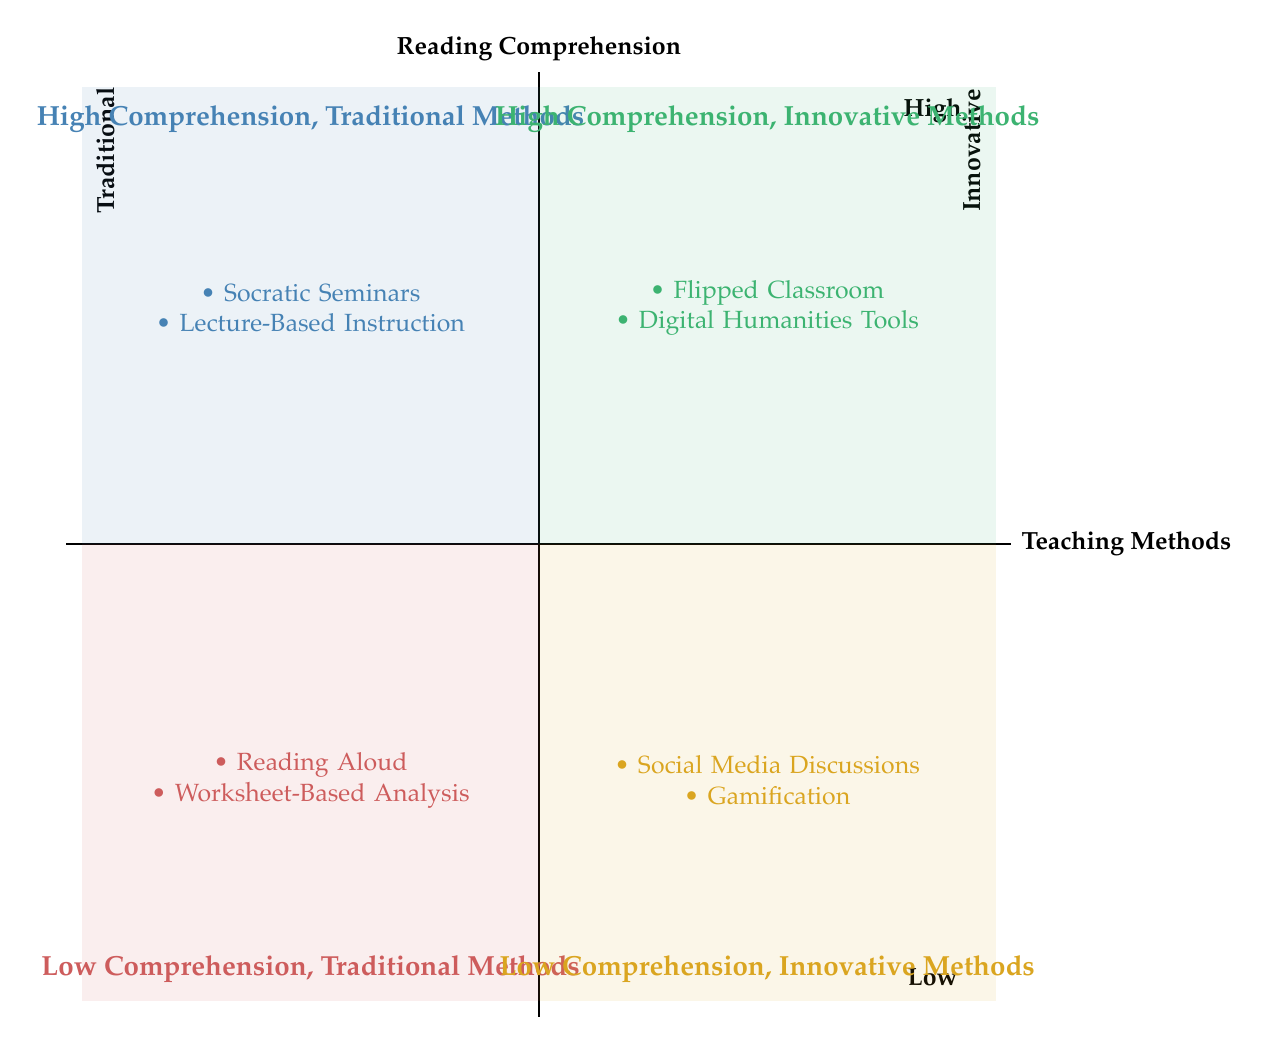What teaching method is in Quadrant 1? Quadrant 1 lists Socratic Seminars and Lecture-Based Instruction as the teaching methods; the question specifically asks for a method, and the first listed is Socratic Seminars.
Answer: Socratic Seminars How many teaching methods are in Quadrant 3? Quadrant 3 contains two methods: Reading Aloud and Worksheet-Based Analysis; counting the elements gives us the number.
Answer: 2 What is the relationship between innovative methods and high comprehension? Quadrant 2 represents the combination of High Comprehension and Innovative Methods, suggesting a positive relationship between innovation in teaching and comprehension levels.
Answer: Positive relationship Which quadrant contains Gamification? Gamification is listed in Quadrant 4; this quadrant corresponds to Low Comprehension and Innovative Methods.
Answer: Quadrant 4 Which traditional method aims to foster critical thinking? Socratic Seminars is found in Quadrant 1, which indicates that it is a traditional method aimed at fostering critical thinking and comprehension through dialogue.
Answer: Socratic Seminars How many quadrants represent high comprehension? Both Quadrant 1 and Quadrant 2 represent high comprehension; thus, counting these two quadrants provides the answer.
Answer: 2 What type of teaching method is Reading Aloud classified as? Reading Aloud is included in Quadrant 3, which is characterized as a Traditional Method; thus, it is classified as such.
Answer: Traditional Method In which quadrant would you find Digital Humanities Tools? Digital Humanities Tools are listed in Quadrant 2; this corresponds to High Comprehension and Innovative Methods.
Answer: Quadrant 2 Which quadrant emphasizes innovation yet results in low comprehension? Quadrant 4 is characterized by Low Comprehension and Innovative Methods; this is where such efforts result in low comprehension.
Answer: Quadrant 4 